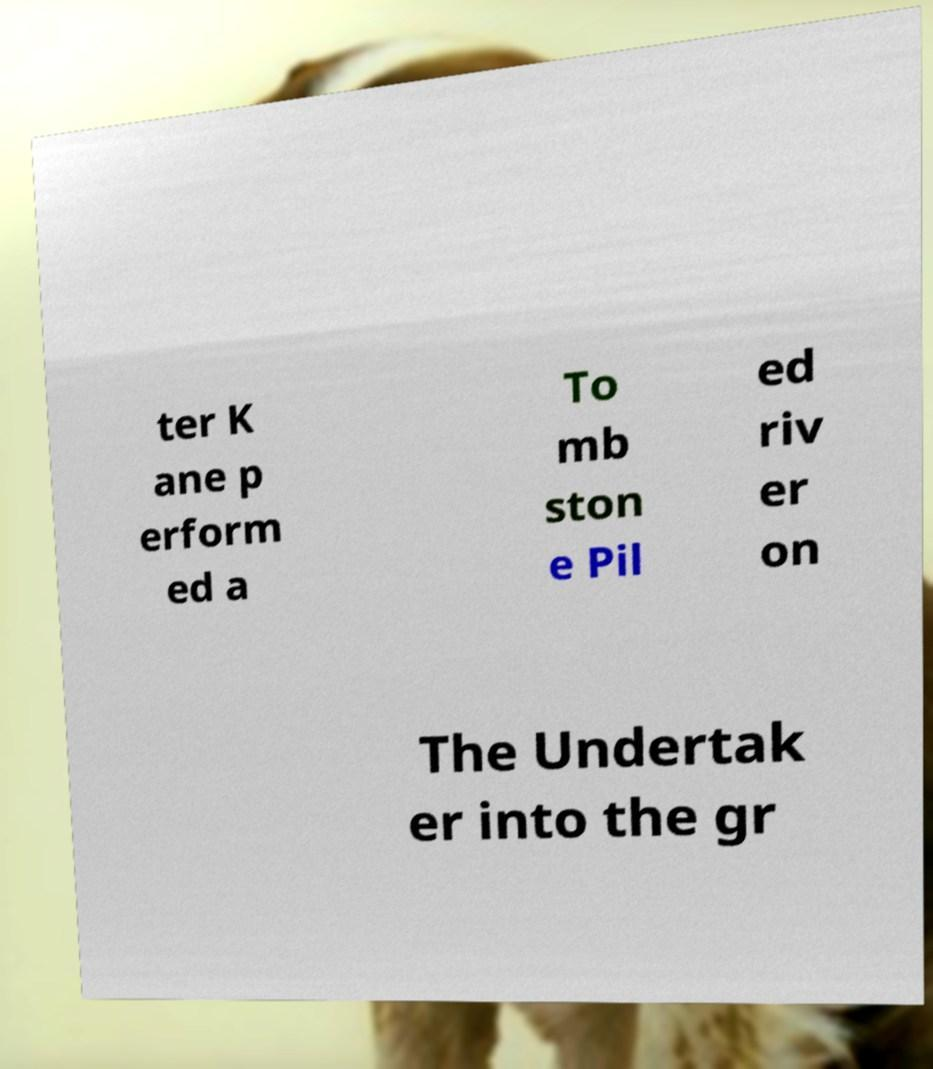Could you assist in decoding the text presented in this image and type it out clearly? ter K ane p erform ed a To mb ston e Pil ed riv er on The Undertak er into the gr 